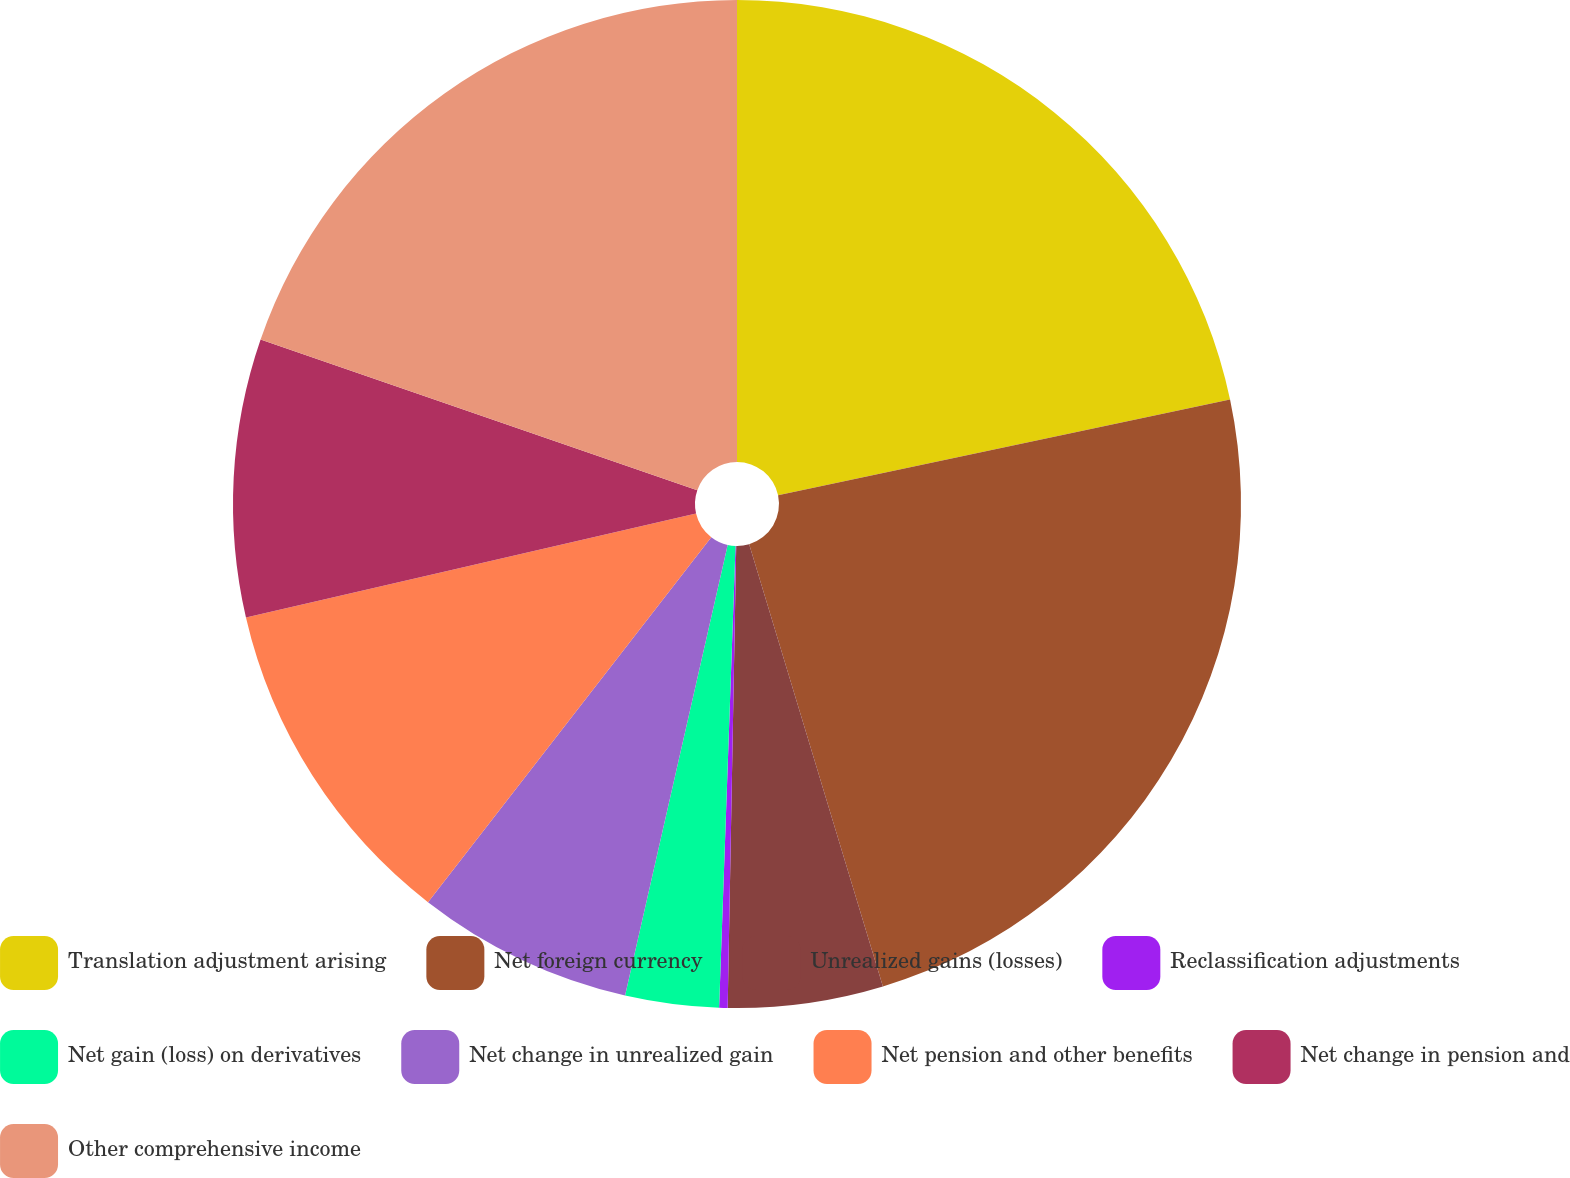Convert chart. <chart><loc_0><loc_0><loc_500><loc_500><pie_chart><fcel>Translation adjustment arising<fcel>Net foreign currency<fcel>Unrealized gains (losses)<fcel>Reclassification adjustments<fcel>Net gain (loss) on derivatives<fcel>Net change in unrealized gain<fcel>Net pension and other benefits<fcel>Net change in pension and<fcel>Other comprehensive income<nl><fcel>21.68%<fcel>23.65%<fcel>4.97%<fcel>0.27%<fcel>3.0%<fcel>6.94%<fcel>10.88%<fcel>8.91%<fcel>19.71%<nl></chart> 